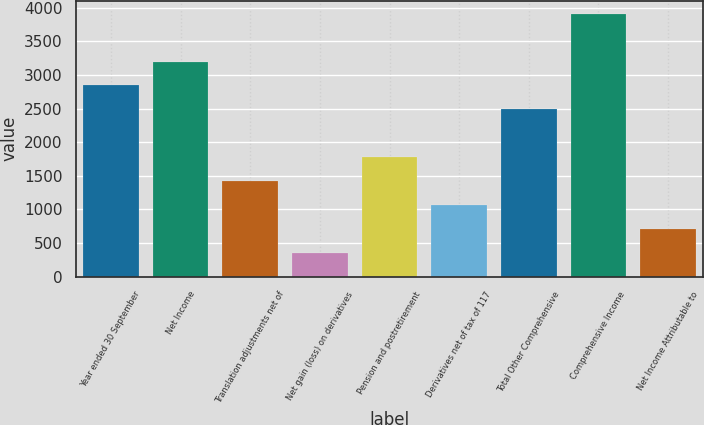<chart> <loc_0><loc_0><loc_500><loc_500><bar_chart><fcel>Year ended 30 September<fcel>Net Income<fcel>Translation adjustments net of<fcel>Net gain (loss) on derivatives<fcel>Pension and postretirement<fcel>Derivatives net of tax of 117<fcel>Total Other Comprehensive<fcel>Comprehensive Income<fcel>Net Income Attributable to<nl><fcel>2844.18<fcel>3199.24<fcel>1423.94<fcel>358.76<fcel>1779<fcel>1068.88<fcel>2489.12<fcel>3909.36<fcel>713.82<nl></chart> 